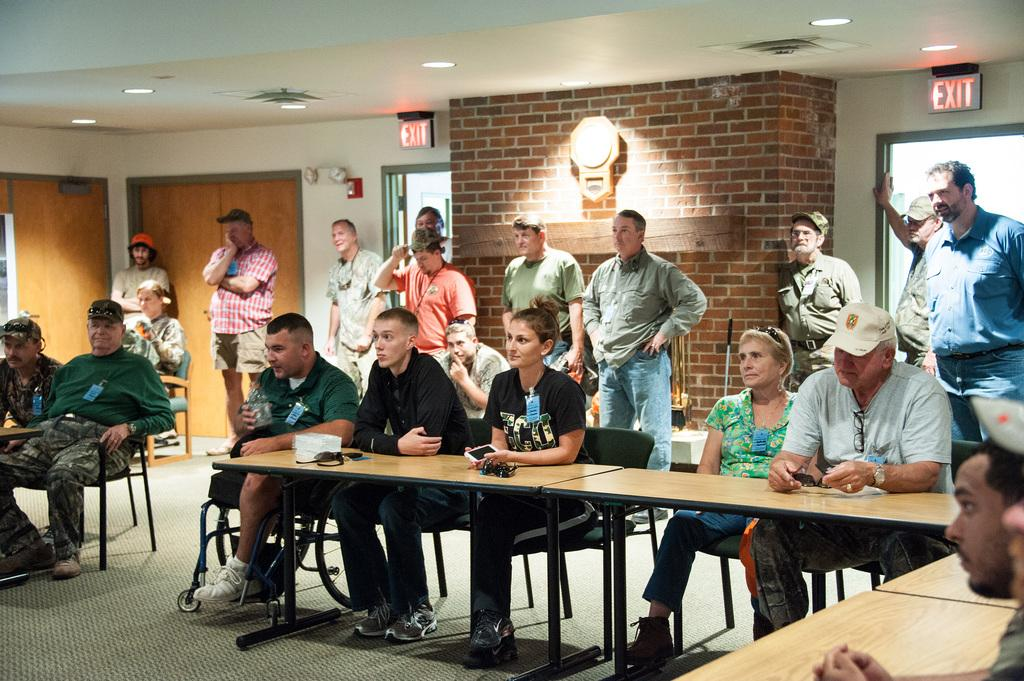How many people are in the image? There is a group of people in the image. What are some of the people doing in the image? Some people are sitting on chairs, while others are standing on the floor. Where are the chairs located in relation to the table? The chairs are in front of a table. What type of amusement can be seen in the sky in the image? There is no amusement or sky visible in the image; it only shows a group of people, chairs, and a table. 